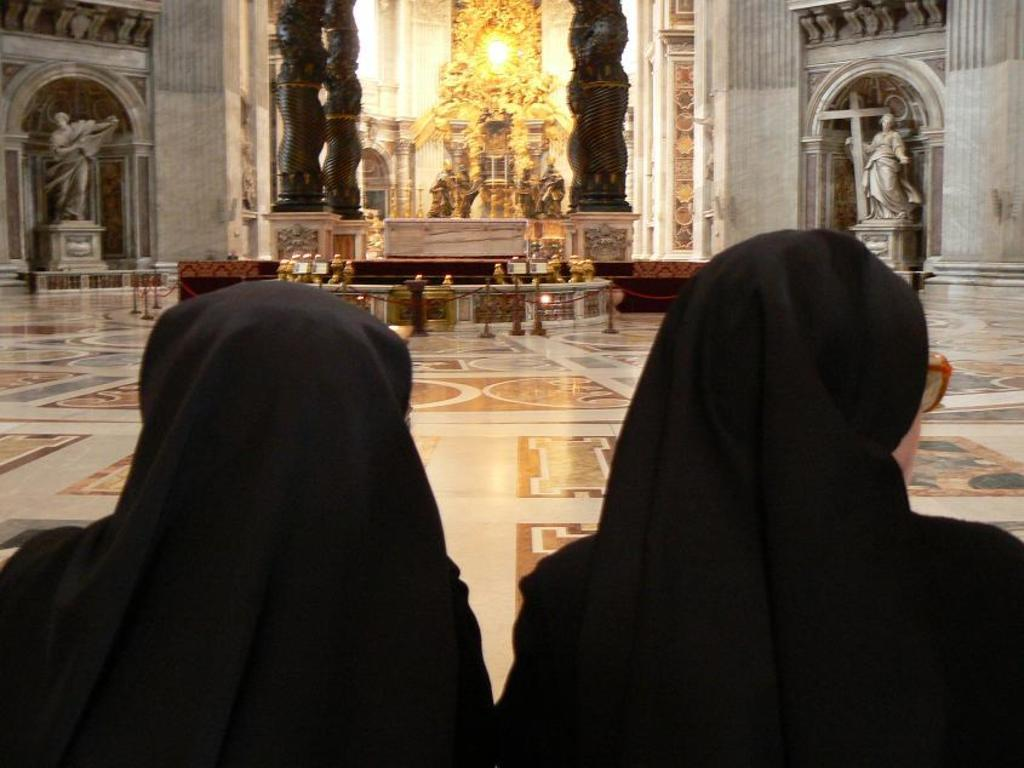How many people are in the image? There are two women in the image. What can be seen in the background of the image? There are statues, metal rods, and a light in the background of the image. Where are the cows located in the image? There are no cows present in the image. 